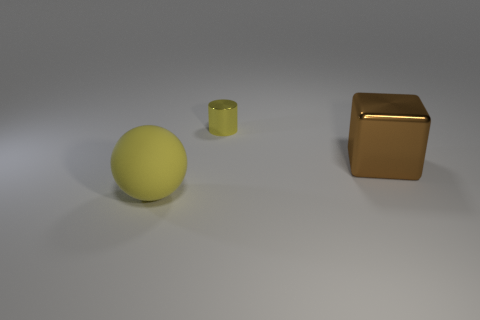Is there any other thing that has the same size as the yellow metallic object?
Provide a succinct answer. No. Is there anything else that has the same material as the big ball?
Offer a terse response. No. There is a object that is to the left of the yellow cylinder; does it have the same size as the thing behind the big shiny thing?
Make the answer very short. No. What is the color of the big object behind the matte sphere?
Give a very brief answer. Brown. Is the number of tiny shiny things in front of the large rubber ball less than the number of large cubes?
Your answer should be compact. Yes. Do the large ball and the small cylinder have the same material?
Give a very brief answer. No. What number of things are things behind the rubber thing or things that are to the right of the tiny cylinder?
Ensure brevity in your answer.  2. Are there fewer blue rubber cylinders than blocks?
Provide a short and direct response. Yes. Do the brown metal block and the yellow thing behind the matte sphere have the same size?
Your answer should be very brief. No. What number of matte things are green cylinders or big blocks?
Ensure brevity in your answer.  0. 